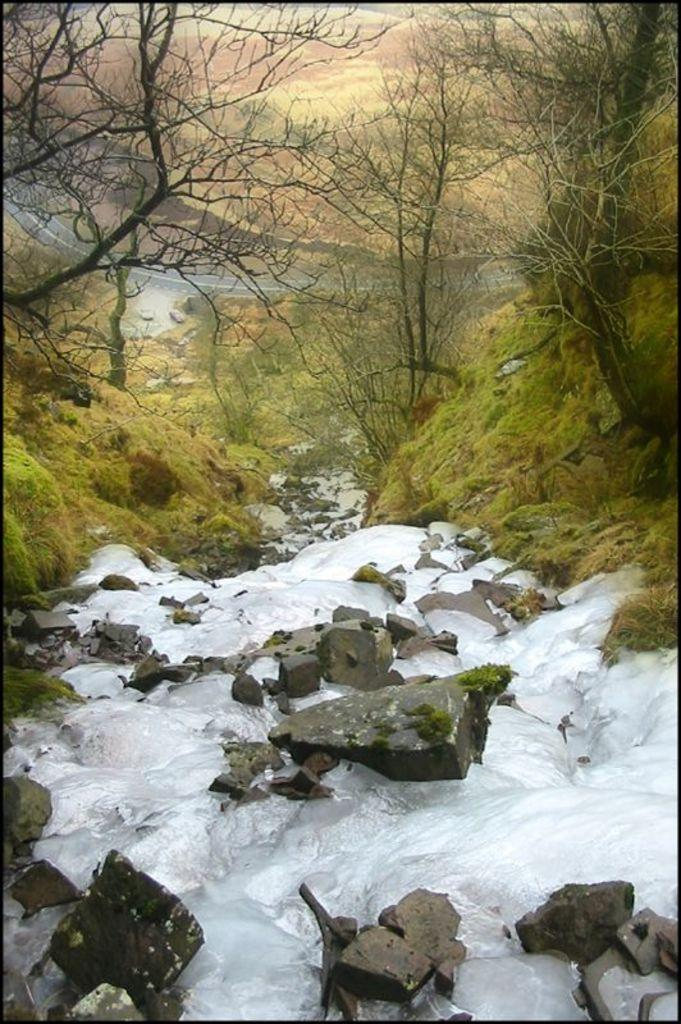What is the primary element visible in the image? There is water in the image. What other objects or features can be seen in the image? There are stones and grass visible in the image. What can be seen in the background of the image? There are trees visible in the background of the image. What type of bait is being used to catch fish in the image? There is no fishing or bait present in the image; it features water, stones, grass, and trees. How many people are pushing the stones in the image? There are no people pushing stones in the image; it only shows water, stones, grass, and trees. 